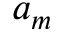Convert formula to latex. <formula><loc_0><loc_0><loc_500><loc_500>a _ { m }</formula> 